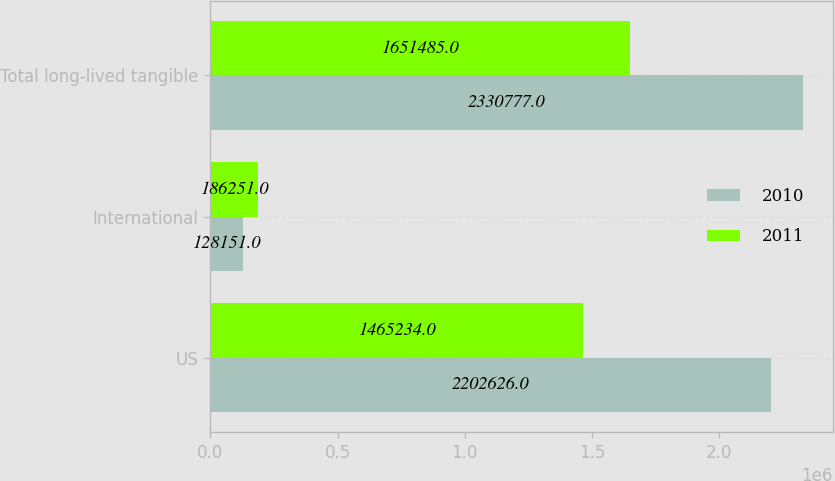Convert chart to OTSL. <chart><loc_0><loc_0><loc_500><loc_500><stacked_bar_chart><ecel><fcel>US<fcel>International<fcel>Total long-lived tangible<nl><fcel>2010<fcel>2.20263e+06<fcel>128151<fcel>2.33078e+06<nl><fcel>2011<fcel>1.46523e+06<fcel>186251<fcel>1.65148e+06<nl></chart> 